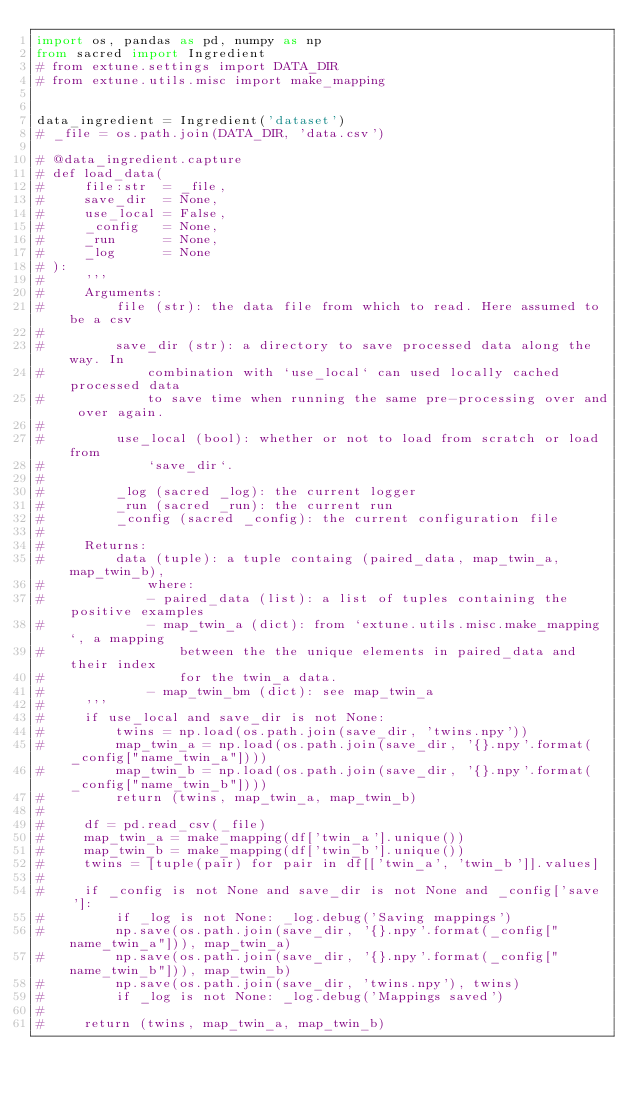Convert code to text. <code><loc_0><loc_0><loc_500><loc_500><_Python_>import os, pandas as pd, numpy as np
from sacred import Ingredient
# from extune.settings import DATA_DIR
# from extune.utils.misc import make_mapping


data_ingredient = Ingredient('dataset')
# _file = os.path.join(DATA_DIR, 'data.csv')

# @data_ingredient.capture
# def load_data(
#     file:str  = _file,
#     save_dir  = None,
#     use_local = False,
#     _config   = None,
#     _run      = None,
#     _log      = None
# ):
#     '''
#     Arguments:
#         file (str): the data file from which to read. Here assumed to be a csv
#
#         save_dir (str): a directory to save processed data along the way. In
#             combination with `use_local` can used locally cached processed data
#             to save time when running the same pre-processing over and over again.
#
#         use_local (bool): whether or not to load from scratch or load from
#             `save_dir`.
#
#         _log (sacred _log): the current logger
#         _run (sacred _run): the current run
#         _config (sacred _config): the current configuration file
#
#     Returns:
#         data (tuple): a tuple containg (paired_data, map_twin_a, map_twin_b),
#             where:
#             - paired_data (list): a list of tuples containing the positive examples
#             - map_twin_a (dict): from `extune.utils.misc.make_mapping`, a mapping
#                 between the the unique elements in paired_data and their index
#                 for the twin_a data.
#             - map_twin_bm (dict): see map_twin_a
#     '''
#     if use_local and save_dir is not None:
#         twins = np.load(os.path.join(save_dir, 'twins.npy'))
#         map_twin_a = np.load(os.path.join(save_dir, '{}.npy'.format(_config["name_twin_a"])))
#         map_twin_b = np.load(os.path.join(save_dir, '{}.npy'.format(_config["name_twin_b"])))
#         return (twins, map_twin_a, map_twin_b)
#
#     df = pd.read_csv(_file)
#     map_twin_a = make_mapping(df['twin_a'].unique())
#     map_twin_b = make_mapping(df['twin_b'].unique())
#     twins = [tuple(pair) for pair in df[['twin_a', 'twin_b']].values]
#
#     if _config is not None and save_dir is not None and _config['save']:
#         if _log is not None: _log.debug('Saving mappings')
#         np.save(os.path.join(save_dir, '{}.npy'.format(_config["name_twin_a"])), map_twin_a)
#         np.save(os.path.join(save_dir, '{}.npy'.format(_config["name_twin_b"])), map_twin_b)
#         np.save(os.path.join(save_dir, 'twins.npy'), twins)
#         if _log is not None: _log.debug('Mappings saved')
#
#     return (twins, map_twin_a, map_twin_b)
</code> 